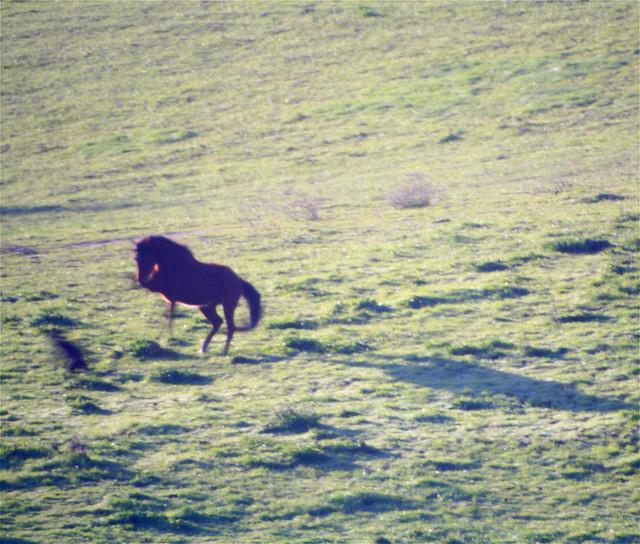How many people are there?
Short answer required. 0. Is the horse in motion?
Answer briefly. Yes. Where is the horse's shadow?
Short answer required. Black. 